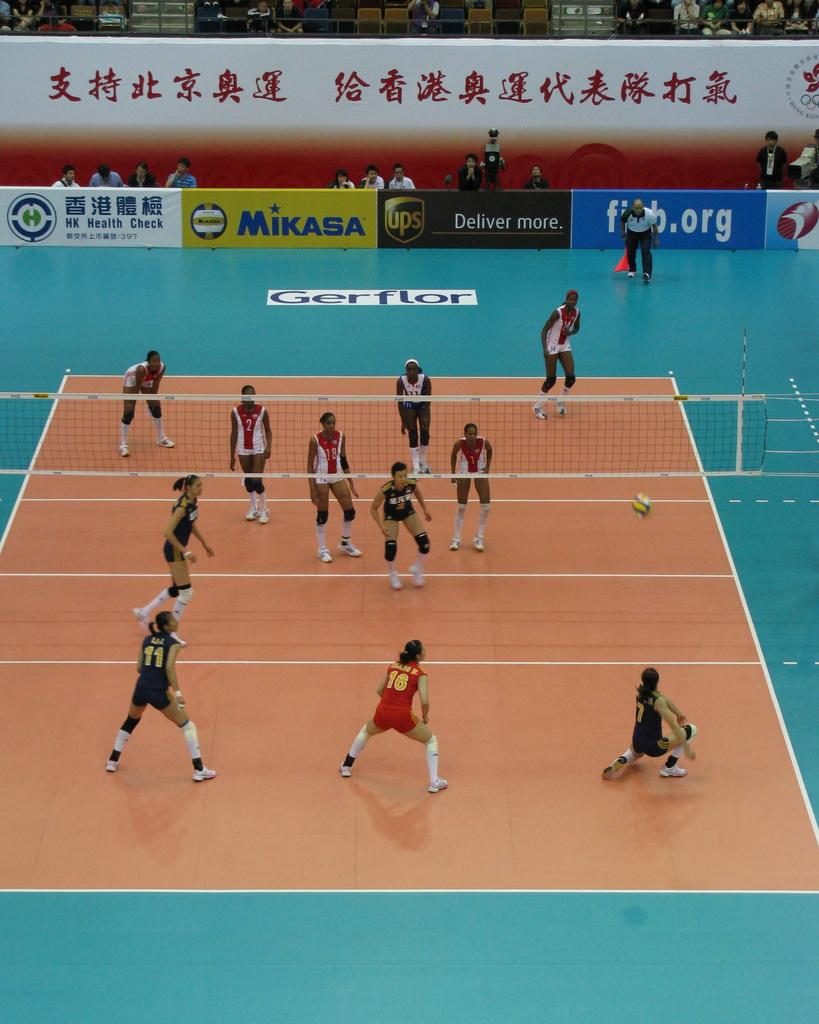<image>
Provide a brief description of the given image. A volleyball match takes place on a court surrounded with advertising from Mikasa,UPS and others. 